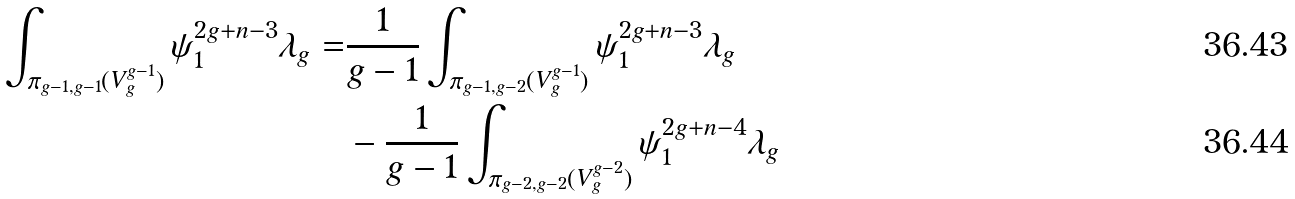<formula> <loc_0><loc_0><loc_500><loc_500>\int _ { \pi _ { g - 1 , g - 1 } ( V _ { g } ^ { g - 1 } ) } \psi _ { 1 } ^ { 2 g + n - 3 } \lambda _ { g } = & \frac { 1 } { g - 1 } \int _ { \pi _ { g - 1 , g - 2 } ( V _ { g } ^ { g - 1 } ) } \psi _ { 1 } ^ { 2 g + n - 3 } \lambda _ { g } \\ & - \frac { 1 } { g - 1 } \int _ { \pi _ { g - 2 , g - 2 } ( V _ { g } ^ { g - 2 } ) } \psi _ { 1 } ^ { 2 g + n - 4 } \lambda _ { g }</formula> 